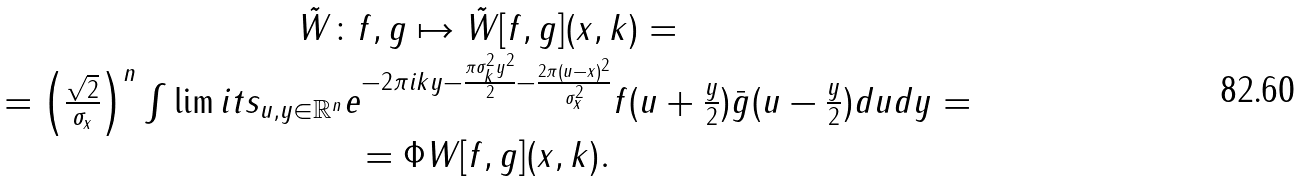<formula> <loc_0><loc_0><loc_500><loc_500>\begin{array} { c } \tilde { W } \colon f , g \mapsto \tilde { W } [ f , g ] ( x , k ) = \\ = \left ( { \frac { \sqrt { 2 } } { \sigma _ { x } } } \right ) ^ { n } \int \lim i t s _ { u , y \in \mathbb { R } ^ { n } } { e ^ { - 2 \pi i k y - \frac { \pi \sigma _ { k } ^ { 2 } y ^ { 2 } } { 2 } - \frac { 2 \pi ( u - x ) ^ { 2 } } { \sigma _ { x } ^ { 2 } } } f ( u + \frac { y } { 2 } ) \bar { g } ( u - \frac { y } { 2 } ) d u d y } = \\ = \Phi W [ f , g ] ( x , k ) . \end{array}</formula> 